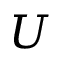Convert formula to latex. <formula><loc_0><loc_0><loc_500><loc_500>U</formula> 